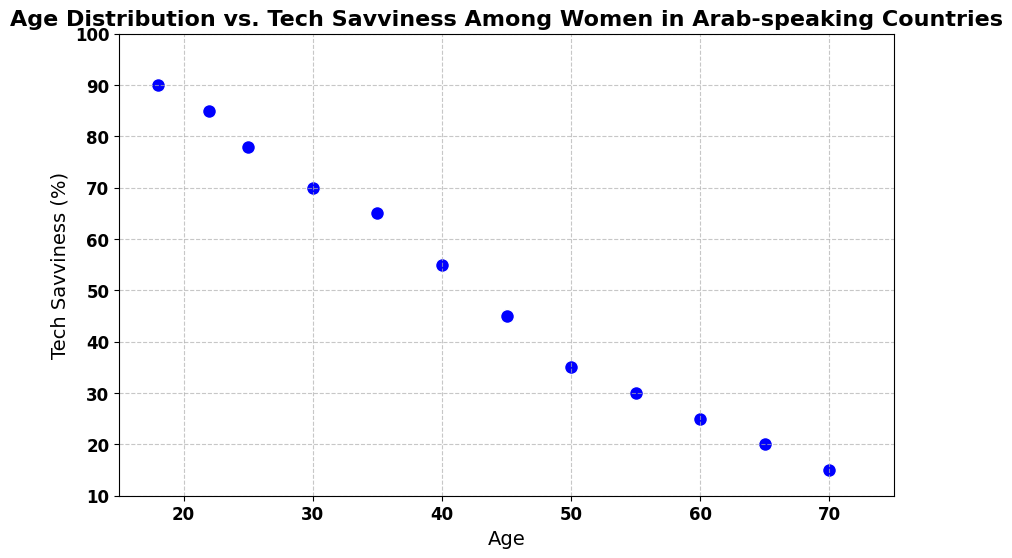What is the average Tech Savviness percentage for women aged 30 and 40? First, we find the Tech Savviness percentages for ages 30 and 40, which are 70 and 55. Adding these values gives 125. Dividing by the number of ages (2) results in an average of 125/2 = 62.5.
Answer: 62.5 Which age group has the highest Tech Savviness? By looking at the scatter plot, the highest Tech Savviness value is 90, observed at age 18.
Answer: 18 How much does Tech Savviness decline from age 18 to age 30? The Tech Savviness value at age 18 is 90, and at age 30, it is 70. Subtract 70 from 90 to get the decline: 90 - 70 = 20.
Answer: 20 Is the Tech Savviness of women aged 50 greater than that of women aged 60? From the scatter plot, Tech Savviness at age 50 is 35, and at age 60, it is 25. Since 35 is greater than 25, the answer is yes.
Answer: Yes What's the difference in Tech Savviness between the youngest and oldest age groups? The youngest age group (18) has a Tech Savviness of 90, and the oldest age group (70) has a Tech Savviness of 15. The difference is 90 - 15 = 75.
Answer: 75 What is the median Tech Savviness value for the given age groups? The Tech Savviness values are: 90, 85, 78, 70, 65, 55, 45, 35, 30, 25, 20, 15. Arranging these in ascending order gives: 15, 20, 25, 30, 35, 45, 55, 65, 70, 78, 85, 90. The median value is the average of the 6th and 7th values: (45 + 55)/2 = 50.
Answer: 50 Which age group has a Tech Savviness just below 50%? From the scatter plot, the Tech Savviness values in descending order around 50% are 55 for age 40 and 45 for age 45. The age group just below 50% is 45.
Answer: 45 How does the Tech Savviness change visually as age increases? Visually, the scatter plot shows a downward trend. As age increases from 18 to 70, the Tech Savviness percentages progressively decrease. The points form a clear declining pattern from top left to bottom right.
Answer: Declines In which age group does Tech Savviness see the steepest drop? By examining the scatter plot, the Tech Savviness sees the steepest drop between ages 45 and 50, where it falls from 45 to 35, showing a 10-point drop.
Answer: 45 to 50 